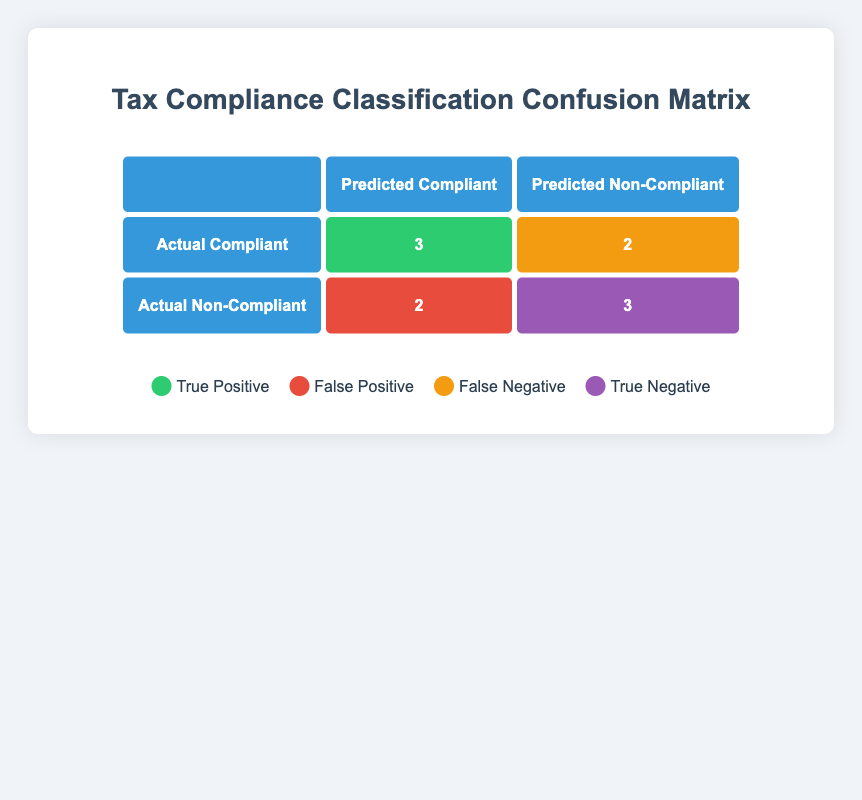What is the total number of true positives in the confusion matrix? The true positives are represented by the count in the cell for Actual Compliant and Predicted Compliant. According to the table, there are 3 true positives.
Answer: 3 What is the number of false negatives in the confusion matrix? The false negatives are found in the cell for Actual Compliant and Predicted Non-Compliant. This cell shows a count of 2.
Answer: 2 How many corporations were correctly predicted as non-compliant? The correctly predicted non-compliant corporations are represented by the true negatives in the matrix, which is the count in the cell for Actual Non-Compliant and Predicted Non-Compliant. The count here is 3.
Answer: 3 What is the total number of corporations that are actually compliant? The total number of corporations that are actually compliant can be calculated by adding true positives and false negatives. There are 3 true positives and 2 false negatives, giving us 3 + 2 = 5.
Answer: 5 What percentage of corporations did the model incorrectly predict as compliant? To determine this, we need the false positive count which is 2. The total predictions made on non-compliant corporations is 2 (false positives) + 3 (true negatives) = 5. Thus, the percentage is (2/5) * 100 = 40%.
Answer: 40% Are all corporations predicted as compliant actually compliant? Checking the matrix, there are 2 cases of false negatives where compliant corporations were incorrectly predicted as non-compliant. Hence, not all corporations predicted as compliant are actually compliant.
Answer: No What is the difference in the number of true positives and true negatives? The difference is calculated by taking the number of true positives (3) and subtracting the number of true negatives (3). So, 3 - 3 = 0, meaning there is no difference.
Answer: 0 How many corporations were predicted as compliant? We can find this by adding true positives (3) and false positives (2) from the confusion matrix. This leads to a total of 3 + 2 = 5 corporations predicted as compliant.
Answer: 5 How many corporations are wrongly predicted as non-compliant? The wrongly predicted non-compliant corporations are captured by the false negatives which amount to 2 in the matrix.
Answer: 2 